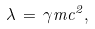<formula> <loc_0><loc_0><loc_500><loc_500>\lambda \, = \, \gamma m c ^ { 2 } ,</formula> 